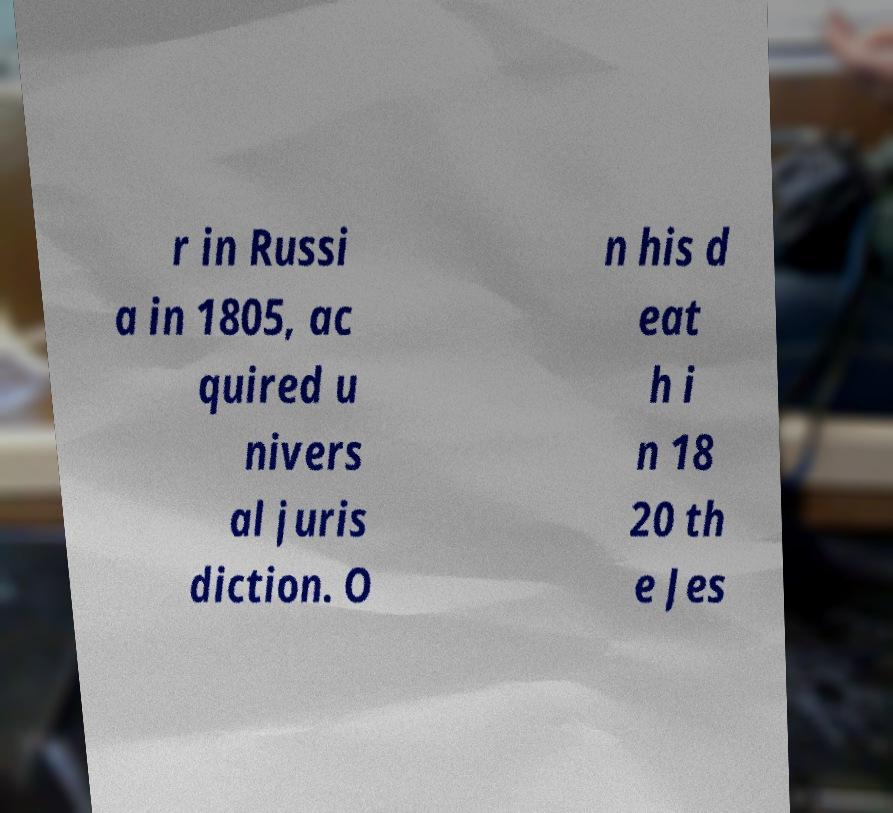What messages or text are displayed in this image? I need them in a readable, typed format. r in Russi a in 1805, ac quired u nivers al juris diction. O n his d eat h i n 18 20 th e Jes 